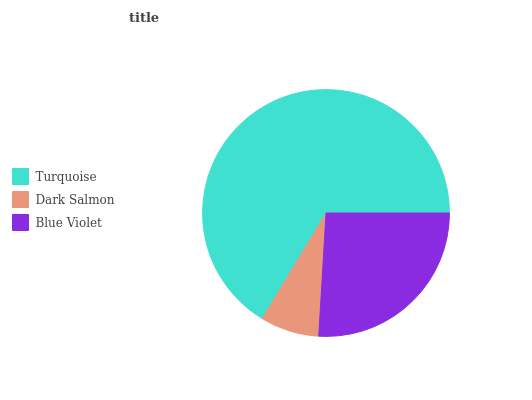Is Dark Salmon the minimum?
Answer yes or no. Yes. Is Turquoise the maximum?
Answer yes or no. Yes. Is Blue Violet the minimum?
Answer yes or no. No. Is Blue Violet the maximum?
Answer yes or no. No. Is Blue Violet greater than Dark Salmon?
Answer yes or no. Yes. Is Dark Salmon less than Blue Violet?
Answer yes or no. Yes. Is Dark Salmon greater than Blue Violet?
Answer yes or no. No. Is Blue Violet less than Dark Salmon?
Answer yes or no. No. Is Blue Violet the high median?
Answer yes or no. Yes. Is Blue Violet the low median?
Answer yes or no. Yes. Is Turquoise the high median?
Answer yes or no. No. Is Dark Salmon the low median?
Answer yes or no. No. 